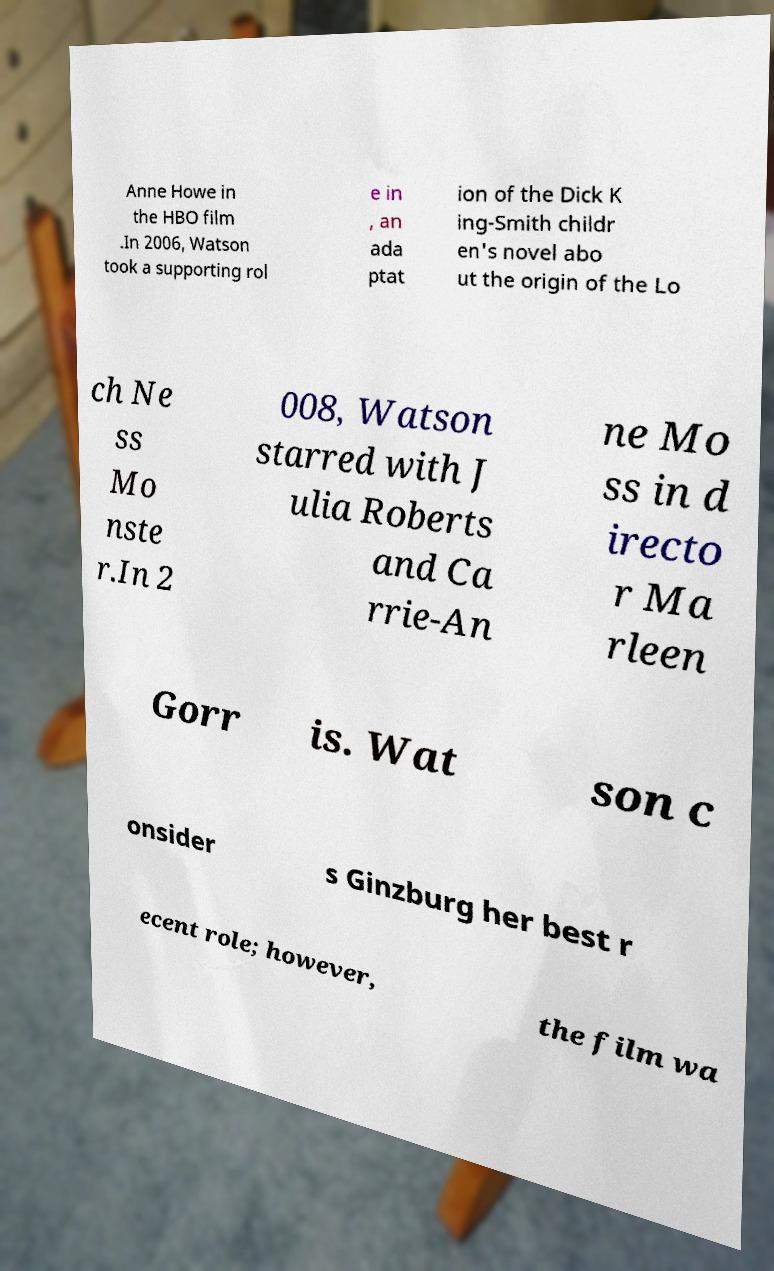There's text embedded in this image that I need extracted. Can you transcribe it verbatim? Anne Howe in the HBO film .In 2006, Watson took a supporting rol e in , an ada ptat ion of the Dick K ing-Smith childr en's novel abo ut the origin of the Lo ch Ne ss Mo nste r.In 2 008, Watson starred with J ulia Roberts and Ca rrie-An ne Mo ss in d irecto r Ma rleen Gorr is. Wat son c onsider s Ginzburg her best r ecent role; however, the film wa 